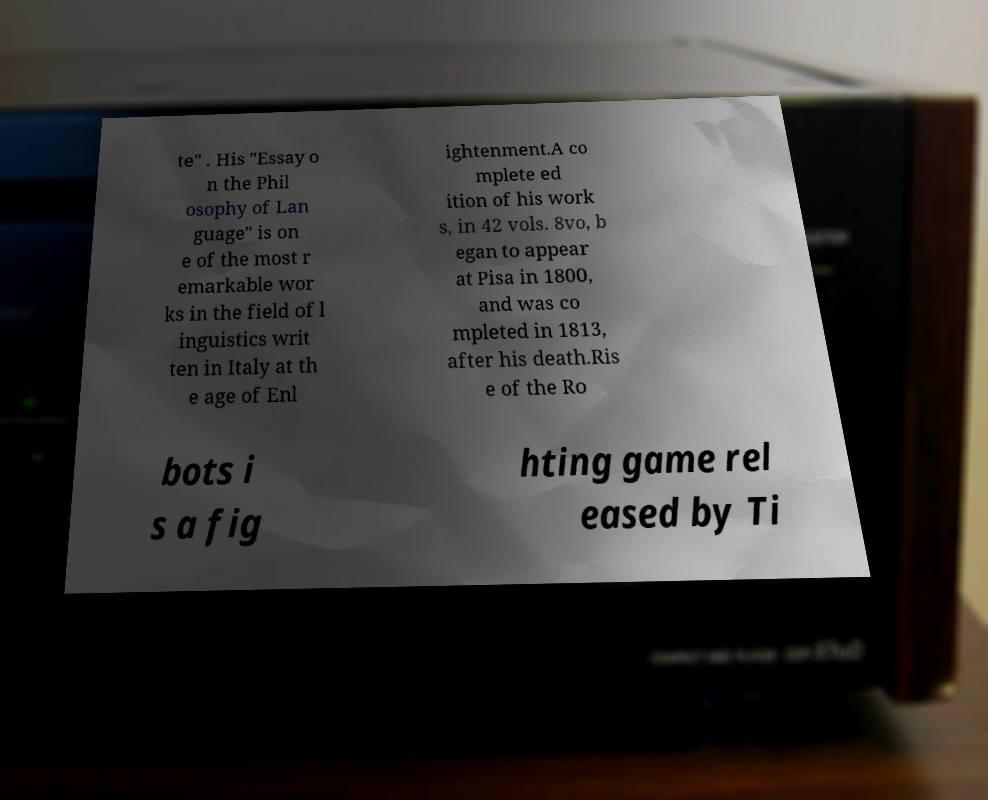Could you assist in decoding the text presented in this image and type it out clearly? te" . His "Essay o n the Phil osophy of Lan guage" is on e of the most r emarkable wor ks in the field of l inguistics writ ten in Italy at th e age of Enl ightenment.A co mplete ed ition of his work s, in 42 vols. 8vo, b egan to appear at Pisa in 1800, and was co mpleted in 1813, after his death.Ris e of the Ro bots i s a fig hting game rel eased by Ti 